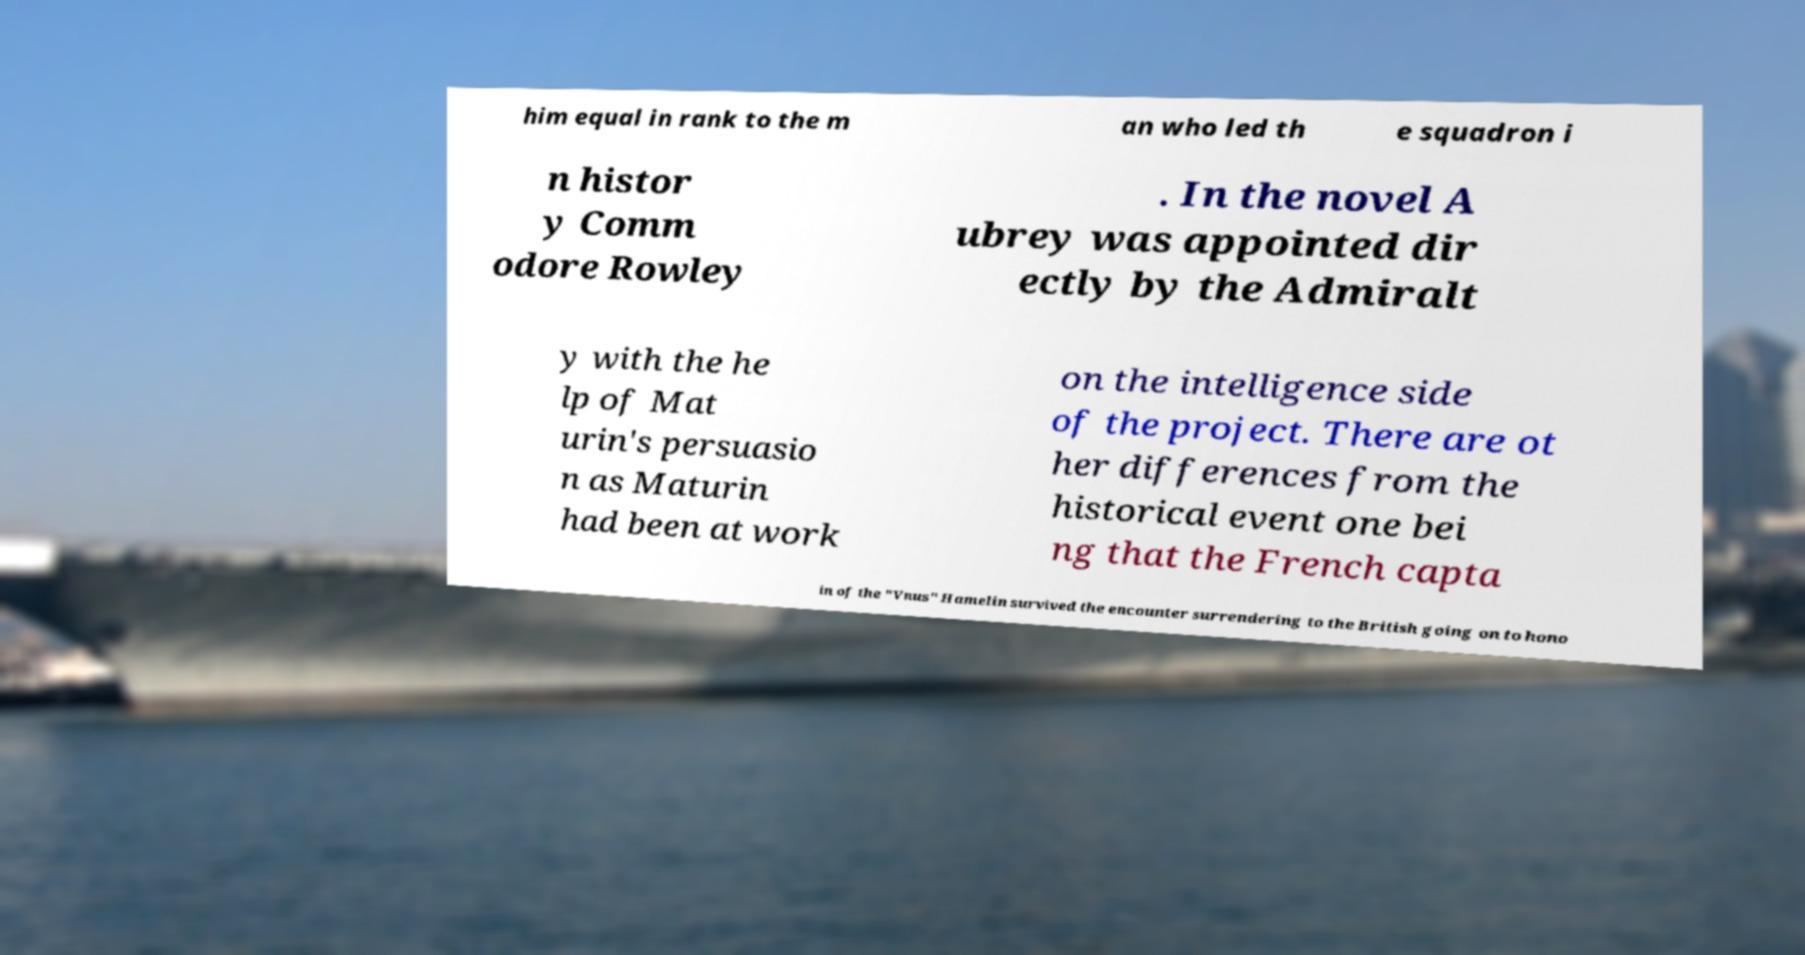I need the written content from this picture converted into text. Can you do that? him equal in rank to the m an who led th e squadron i n histor y Comm odore Rowley . In the novel A ubrey was appointed dir ectly by the Admiralt y with the he lp of Mat urin's persuasio n as Maturin had been at work on the intelligence side of the project. There are ot her differences from the historical event one bei ng that the French capta in of the "Vnus" Hamelin survived the encounter surrendering to the British going on to hono 